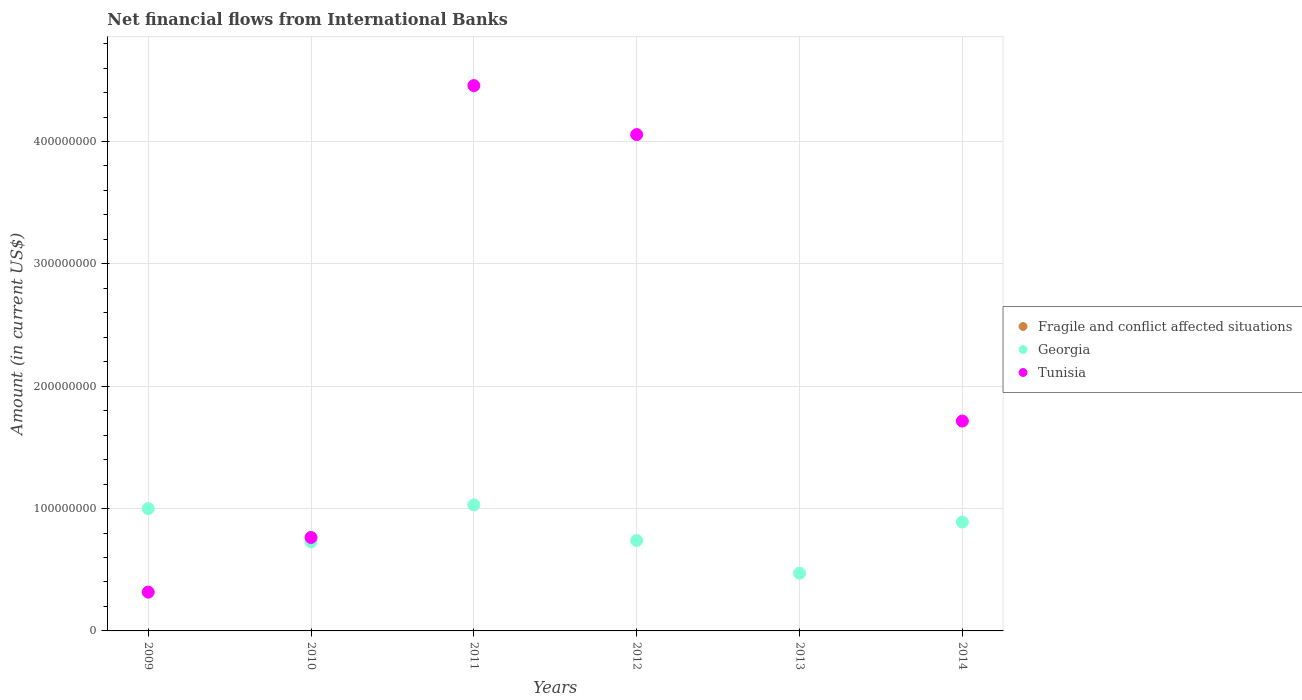Is the number of dotlines equal to the number of legend labels?
Offer a terse response. No. What is the net financial aid flows in Tunisia in 2012?
Give a very brief answer. 4.06e+08. Across all years, what is the maximum net financial aid flows in Tunisia?
Your response must be concise. 4.46e+08. Across all years, what is the minimum net financial aid flows in Georgia?
Your answer should be compact. 4.72e+07. What is the difference between the net financial aid flows in Tunisia in 2010 and that in 2011?
Give a very brief answer. -3.69e+08. What is the difference between the net financial aid flows in Tunisia in 2012 and the net financial aid flows in Fragile and conflict affected situations in 2010?
Keep it short and to the point. 4.06e+08. What is the average net financial aid flows in Georgia per year?
Offer a terse response. 8.10e+07. In the year 2014, what is the difference between the net financial aid flows in Tunisia and net financial aid flows in Georgia?
Your answer should be very brief. 8.26e+07. In how many years, is the net financial aid flows in Tunisia greater than 80000000 US$?
Provide a short and direct response. 3. What is the ratio of the net financial aid flows in Georgia in 2011 to that in 2012?
Your response must be concise. 1.39. What is the difference between the highest and the second highest net financial aid flows in Tunisia?
Give a very brief answer. 4.00e+07. What is the difference between the highest and the lowest net financial aid flows in Tunisia?
Keep it short and to the point. 4.46e+08. Does the net financial aid flows in Georgia monotonically increase over the years?
Ensure brevity in your answer.  No. Is the net financial aid flows in Georgia strictly less than the net financial aid flows in Fragile and conflict affected situations over the years?
Keep it short and to the point. No. What is the difference between two consecutive major ticks on the Y-axis?
Provide a short and direct response. 1.00e+08. Where does the legend appear in the graph?
Provide a short and direct response. Center right. How many legend labels are there?
Offer a terse response. 3. How are the legend labels stacked?
Your response must be concise. Vertical. What is the title of the graph?
Provide a succinct answer. Net financial flows from International Banks. Does "Korea (Republic)" appear as one of the legend labels in the graph?
Make the answer very short. No. What is the label or title of the Y-axis?
Provide a short and direct response. Amount (in current US$). What is the Amount (in current US$) of Fragile and conflict affected situations in 2009?
Give a very brief answer. 0. What is the Amount (in current US$) in Georgia in 2009?
Offer a terse response. 1.00e+08. What is the Amount (in current US$) of Tunisia in 2009?
Give a very brief answer. 3.17e+07. What is the Amount (in current US$) of Fragile and conflict affected situations in 2010?
Provide a succinct answer. 0. What is the Amount (in current US$) in Georgia in 2010?
Give a very brief answer. 7.28e+07. What is the Amount (in current US$) in Tunisia in 2010?
Make the answer very short. 7.64e+07. What is the Amount (in current US$) in Georgia in 2011?
Keep it short and to the point. 1.03e+08. What is the Amount (in current US$) in Tunisia in 2011?
Keep it short and to the point. 4.46e+08. What is the Amount (in current US$) of Georgia in 2012?
Your answer should be very brief. 7.39e+07. What is the Amount (in current US$) of Tunisia in 2012?
Give a very brief answer. 4.06e+08. What is the Amount (in current US$) in Fragile and conflict affected situations in 2013?
Ensure brevity in your answer.  0. What is the Amount (in current US$) of Georgia in 2013?
Your answer should be compact. 4.72e+07. What is the Amount (in current US$) of Georgia in 2014?
Keep it short and to the point. 8.90e+07. What is the Amount (in current US$) in Tunisia in 2014?
Provide a short and direct response. 1.72e+08. Across all years, what is the maximum Amount (in current US$) in Georgia?
Keep it short and to the point. 1.03e+08. Across all years, what is the maximum Amount (in current US$) of Tunisia?
Offer a terse response. 4.46e+08. Across all years, what is the minimum Amount (in current US$) of Georgia?
Your answer should be very brief. 4.72e+07. Across all years, what is the minimum Amount (in current US$) in Tunisia?
Offer a very short reply. 0. What is the total Amount (in current US$) in Georgia in the graph?
Ensure brevity in your answer.  4.86e+08. What is the total Amount (in current US$) in Tunisia in the graph?
Your answer should be very brief. 1.13e+09. What is the difference between the Amount (in current US$) in Georgia in 2009 and that in 2010?
Offer a terse response. 2.71e+07. What is the difference between the Amount (in current US$) in Tunisia in 2009 and that in 2010?
Keep it short and to the point. -4.47e+07. What is the difference between the Amount (in current US$) in Georgia in 2009 and that in 2011?
Provide a short and direct response. -3.01e+06. What is the difference between the Amount (in current US$) in Tunisia in 2009 and that in 2011?
Your answer should be compact. -4.14e+08. What is the difference between the Amount (in current US$) in Georgia in 2009 and that in 2012?
Ensure brevity in your answer.  2.61e+07. What is the difference between the Amount (in current US$) of Tunisia in 2009 and that in 2012?
Your answer should be compact. -3.74e+08. What is the difference between the Amount (in current US$) of Georgia in 2009 and that in 2013?
Your response must be concise. 5.28e+07. What is the difference between the Amount (in current US$) in Georgia in 2009 and that in 2014?
Offer a terse response. 1.10e+07. What is the difference between the Amount (in current US$) of Tunisia in 2009 and that in 2014?
Offer a very short reply. -1.40e+08. What is the difference between the Amount (in current US$) of Georgia in 2010 and that in 2011?
Your answer should be very brief. -3.01e+07. What is the difference between the Amount (in current US$) in Tunisia in 2010 and that in 2011?
Give a very brief answer. -3.69e+08. What is the difference between the Amount (in current US$) of Georgia in 2010 and that in 2012?
Provide a succinct answer. -1.02e+06. What is the difference between the Amount (in current US$) in Tunisia in 2010 and that in 2012?
Your answer should be very brief. -3.29e+08. What is the difference between the Amount (in current US$) of Georgia in 2010 and that in 2013?
Provide a succinct answer. 2.57e+07. What is the difference between the Amount (in current US$) of Georgia in 2010 and that in 2014?
Ensure brevity in your answer.  -1.61e+07. What is the difference between the Amount (in current US$) in Tunisia in 2010 and that in 2014?
Provide a short and direct response. -9.52e+07. What is the difference between the Amount (in current US$) of Georgia in 2011 and that in 2012?
Your answer should be compact. 2.91e+07. What is the difference between the Amount (in current US$) of Tunisia in 2011 and that in 2012?
Your answer should be compact. 4.00e+07. What is the difference between the Amount (in current US$) in Georgia in 2011 and that in 2013?
Your answer should be very brief. 5.58e+07. What is the difference between the Amount (in current US$) in Georgia in 2011 and that in 2014?
Provide a succinct answer. 1.40e+07. What is the difference between the Amount (in current US$) of Tunisia in 2011 and that in 2014?
Ensure brevity in your answer.  2.74e+08. What is the difference between the Amount (in current US$) of Georgia in 2012 and that in 2013?
Keep it short and to the point. 2.67e+07. What is the difference between the Amount (in current US$) in Georgia in 2012 and that in 2014?
Make the answer very short. -1.51e+07. What is the difference between the Amount (in current US$) in Tunisia in 2012 and that in 2014?
Offer a terse response. 2.34e+08. What is the difference between the Amount (in current US$) of Georgia in 2013 and that in 2014?
Offer a very short reply. -4.18e+07. What is the difference between the Amount (in current US$) in Georgia in 2009 and the Amount (in current US$) in Tunisia in 2010?
Provide a succinct answer. 2.36e+07. What is the difference between the Amount (in current US$) of Georgia in 2009 and the Amount (in current US$) of Tunisia in 2011?
Ensure brevity in your answer.  -3.46e+08. What is the difference between the Amount (in current US$) of Georgia in 2009 and the Amount (in current US$) of Tunisia in 2012?
Ensure brevity in your answer.  -3.06e+08. What is the difference between the Amount (in current US$) in Georgia in 2009 and the Amount (in current US$) in Tunisia in 2014?
Provide a short and direct response. -7.16e+07. What is the difference between the Amount (in current US$) of Georgia in 2010 and the Amount (in current US$) of Tunisia in 2011?
Give a very brief answer. -3.73e+08. What is the difference between the Amount (in current US$) of Georgia in 2010 and the Amount (in current US$) of Tunisia in 2012?
Give a very brief answer. -3.33e+08. What is the difference between the Amount (in current US$) in Georgia in 2010 and the Amount (in current US$) in Tunisia in 2014?
Your answer should be very brief. -9.87e+07. What is the difference between the Amount (in current US$) of Georgia in 2011 and the Amount (in current US$) of Tunisia in 2012?
Keep it short and to the point. -3.03e+08. What is the difference between the Amount (in current US$) in Georgia in 2011 and the Amount (in current US$) in Tunisia in 2014?
Offer a very short reply. -6.86e+07. What is the difference between the Amount (in current US$) in Georgia in 2012 and the Amount (in current US$) in Tunisia in 2014?
Offer a terse response. -9.77e+07. What is the difference between the Amount (in current US$) in Georgia in 2013 and the Amount (in current US$) in Tunisia in 2014?
Make the answer very short. -1.24e+08. What is the average Amount (in current US$) of Fragile and conflict affected situations per year?
Provide a succinct answer. 0. What is the average Amount (in current US$) in Georgia per year?
Keep it short and to the point. 8.10e+07. What is the average Amount (in current US$) in Tunisia per year?
Your response must be concise. 1.89e+08. In the year 2009, what is the difference between the Amount (in current US$) in Georgia and Amount (in current US$) in Tunisia?
Your answer should be very brief. 6.83e+07. In the year 2010, what is the difference between the Amount (in current US$) of Georgia and Amount (in current US$) of Tunisia?
Make the answer very short. -3.52e+06. In the year 2011, what is the difference between the Amount (in current US$) of Georgia and Amount (in current US$) of Tunisia?
Provide a short and direct response. -3.43e+08. In the year 2012, what is the difference between the Amount (in current US$) of Georgia and Amount (in current US$) of Tunisia?
Offer a very short reply. -3.32e+08. In the year 2014, what is the difference between the Amount (in current US$) of Georgia and Amount (in current US$) of Tunisia?
Your response must be concise. -8.26e+07. What is the ratio of the Amount (in current US$) in Georgia in 2009 to that in 2010?
Keep it short and to the point. 1.37. What is the ratio of the Amount (in current US$) of Tunisia in 2009 to that in 2010?
Ensure brevity in your answer.  0.41. What is the ratio of the Amount (in current US$) of Georgia in 2009 to that in 2011?
Keep it short and to the point. 0.97. What is the ratio of the Amount (in current US$) of Tunisia in 2009 to that in 2011?
Provide a succinct answer. 0.07. What is the ratio of the Amount (in current US$) of Georgia in 2009 to that in 2012?
Your answer should be compact. 1.35. What is the ratio of the Amount (in current US$) of Tunisia in 2009 to that in 2012?
Ensure brevity in your answer.  0.08. What is the ratio of the Amount (in current US$) in Georgia in 2009 to that in 2013?
Offer a terse response. 2.12. What is the ratio of the Amount (in current US$) of Georgia in 2009 to that in 2014?
Your answer should be very brief. 1.12. What is the ratio of the Amount (in current US$) of Tunisia in 2009 to that in 2014?
Your answer should be compact. 0.18. What is the ratio of the Amount (in current US$) in Georgia in 2010 to that in 2011?
Offer a terse response. 0.71. What is the ratio of the Amount (in current US$) of Tunisia in 2010 to that in 2011?
Keep it short and to the point. 0.17. What is the ratio of the Amount (in current US$) of Georgia in 2010 to that in 2012?
Your answer should be very brief. 0.99. What is the ratio of the Amount (in current US$) of Tunisia in 2010 to that in 2012?
Keep it short and to the point. 0.19. What is the ratio of the Amount (in current US$) in Georgia in 2010 to that in 2013?
Offer a terse response. 1.54. What is the ratio of the Amount (in current US$) in Georgia in 2010 to that in 2014?
Provide a succinct answer. 0.82. What is the ratio of the Amount (in current US$) of Tunisia in 2010 to that in 2014?
Provide a short and direct response. 0.45. What is the ratio of the Amount (in current US$) in Georgia in 2011 to that in 2012?
Your answer should be compact. 1.39. What is the ratio of the Amount (in current US$) of Tunisia in 2011 to that in 2012?
Your answer should be compact. 1.1. What is the ratio of the Amount (in current US$) of Georgia in 2011 to that in 2013?
Provide a short and direct response. 2.18. What is the ratio of the Amount (in current US$) in Georgia in 2011 to that in 2014?
Your answer should be compact. 1.16. What is the ratio of the Amount (in current US$) of Tunisia in 2011 to that in 2014?
Your answer should be very brief. 2.6. What is the ratio of the Amount (in current US$) of Georgia in 2012 to that in 2013?
Your answer should be very brief. 1.57. What is the ratio of the Amount (in current US$) of Georgia in 2012 to that in 2014?
Offer a terse response. 0.83. What is the ratio of the Amount (in current US$) in Tunisia in 2012 to that in 2014?
Keep it short and to the point. 2.36. What is the ratio of the Amount (in current US$) in Georgia in 2013 to that in 2014?
Ensure brevity in your answer.  0.53. What is the difference between the highest and the second highest Amount (in current US$) of Georgia?
Offer a terse response. 3.01e+06. What is the difference between the highest and the second highest Amount (in current US$) in Tunisia?
Ensure brevity in your answer.  4.00e+07. What is the difference between the highest and the lowest Amount (in current US$) of Georgia?
Ensure brevity in your answer.  5.58e+07. What is the difference between the highest and the lowest Amount (in current US$) of Tunisia?
Offer a very short reply. 4.46e+08. 